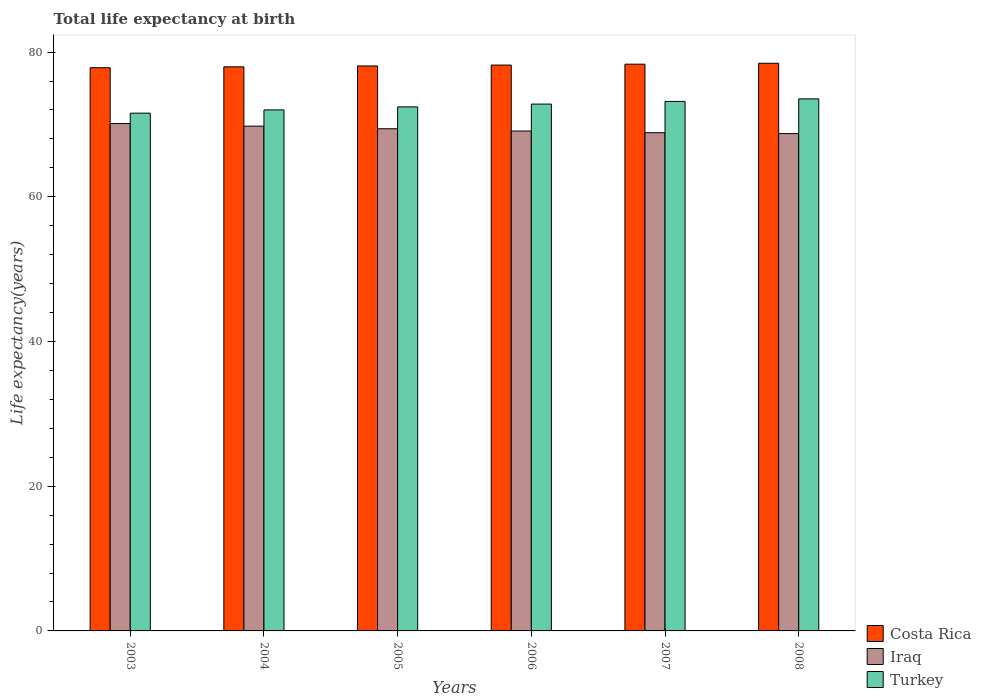How many different coloured bars are there?
Your answer should be very brief. 3. How many groups of bars are there?
Offer a terse response. 6. Are the number of bars per tick equal to the number of legend labels?
Keep it short and to the point. Yes. How many bars are there on the 3rd tick from the right?
Make the answer very short. 3. What is the label of the 6th group of bars from the left?
Make the answer very short. 2008. In how many cases, is the number of bars for a given year not equal to the number of legend labels?
Give a very brief answer. 0. What is the life expectancy at birth in in Costa Rica in 2007?
Your answer should be compact. 78.33. Across all years, what is the maximum life expectancy at birth in in Iraq?
Offer a very short reply. 70.12. Across all years, what is the minimum life expectancy at birth in in Turkey?
Make the answer very short. 71.56. In which year was the life expectancy at birth in in Iraq minimum?
Provide a succinct answer. 2008. What is the total life expectancy at birth in in Iraq in the graph?
Your answer should be compact. 415.99. What is the difference between the life expectancy at birth in in Iraq in 2006 and that in 2008?
Offer a very short reply. 0.36. What is the difference between the life expectancy at birth in in Iraq in 2007 and the life expectancy at birth in in Costa Rica in 2003?
Provide a succinct answer. -8.98. What is the average life expectancy at birth in in Turkey per year?
Give a very brief answer. 72.59. In the year 2003, what is the difference between the life expectancy at birth in in Turkey and life expectancy at birth in in Costa Rica?
Provide a short and direct response. -6.28. What is the ratio of the life expectancy at birth in in Costa Rica in 2003 to that in 2006?
Give a very brief answer. 1. What is the difference between the highest and the second highest life expectancy at birth in in Iraq?
Offer a very short reply. 0.35. What is the difference between the highest and the lowest life expectancy at birth in in Iraq?
Keep it short and to the point. 1.39. In how many years, is the life expectancy at birth in in Costa Rica greater than the average life expectancy at birth in in Costa Rica taken over all years?
Provide a succinct answer. 3. What does the 3rd bar from the left in 2004 represents?
Ensure brevity in your answer.  Turkey. What does the 2nd bar from the right in 2007 represents?
Make the answer very short. Iraq. Are all the bars in the graph horizontal?
Your answer should be compact. No. Are the values on the major ticks of Y-axis written in scientific E-notation?
Offer a terse response. No. Does the graph contain any zero values?
Your answer should be very brief. No. Does the graph contain grids?
Give a very brief answer. No. Where does the legend appear in the graph?
Your answer should be very brief. Bottom right. How are the legend labels stacked?
Keep it short and to the point. Vertical. What is the title of the graph?
Your response must be concise. Total life expectancy at birth. Does "Korea (Republic)" appear as one of the legend labels in the graph?
Your answer should be compact. No. What is the label or title of the Y-axis?
Offer a terse response. Life expectancy(years). What is the Life expectancy(years) of Costa Rica in 2003?
Keep it short and to the point. 77.84. What is the Life expectancy(years) in Iraq in 2003?
Make the answer very short. 70.12. What is the Life expectancy(years) of Turkey in 2003?
Your response must be concise. 71.56. What is the Life expectancy(years) of Costa Rica in 2004?
Provide a short and direct response. 77.97. What is the Life expectancy(years) in Iraq in 2004?
Provide a succinct answer. 69.77. What is the Life expectancy(years) of Turkey in 2004?
Keep it short and to the point. 72.01. What is the Life expectancy(years) in Costa Rica in 2005?
Provide a short and direct response. 78.09. What is the Life expectancy(years) of Iraq in 2005?
Make the answer very short. 69.41. What is the Life expectancy(years) of Turkey in 2005?
Give a very brief answer. 72.43. What is the Life expectancy(years) in Costa Rica in 2006?
Offer a terse response. 78.21. What is the Life expectancy(years) in Iraq in 2006?
Offer a very short reply. 69.09. What is the Life expectancy(years) in Turkey in 2006?
Make the answer very short. 72.82. What is the Life expectancy(years) in Costa Rica in 2007?
Ensure brevity in your answer.  78.33. What is the Life expectancy(years) of Iraq in 2007?
Make the answer very short. 68.86. What is the Life expectancy(years) in Turkey in 2007?
Make the answer very short. 73.18. What is the Life expectancy(years) of Costa Rica in 2008?
Provide a succinct answer. 78.46. What is the Life expectancy(years) in Iraq in 2008?
Provide a short and direct response. 68.73. What is the Life expectancy(years) in Turkey in 2008?
Ensure brevity in your answer.  73.53. Across all years, what is the maximum Life expectancy(years) in Costa Rica?
Provide a short and direct response. 78.46. Across all years, what is the maximum Life expectancy(years) of Iraq?
Ensure brevity in your answer.  70.12. Across all years, what is the maximum Life expectancy(years) in Turkey?
Provide a short and direct response. 73.53. Across all years, what is the minimum Life expectancy(years) of Costa Rica?
Provide a succinct answer. 77.84. Across all years, what is the minimum Life expectancy(years) of Iraq?
Ensure brevity in your answer.  68.73. Across all years, what is the minimum Life expectancy(years) in Turkey?
Offer a terse response. 71.56. What is the total Life expectancy(years) in Costa Rica in the graph?
Offer a very short reply. 468.89. What is the total Life expectancy(years) in Iraq in the graph?
Provide a succinct answer. 415.99. What is the total Life expectancy(years) in Turkey in the graph?
Give a very brief answer. 435.53. What is the difference between the Life expectancy(years) of Costa Rica in 2003 and that in 2004?
Keep it short and to the point. -0.12. What is the difference between the Life expectancy(years) in Iraq in 2003 and that in 2004?
Offer a very short reply. 0.35. What is the difference between the Life expectancy(years) of Turkey in 2003 and that in 2004?
Provide a succinct answer. -0.45. What is the difference between the Life expectancy(years) in Costa Rica in 2003 and that in 2005?
Ensure brevity in your answer.  -0.25. What is the difference between the Life expectancy(years) of Iraq in 2003 and that in 2005?
Offer a very short reply. 0.72. What is the difference between the Life expectancy(years) of Turkey in 2003 and that in 2005?
Ensure brevity in your answer.  -0.87. What is the difference between the Life expectancy(years) of Costa Rica in 2003 and that in 2006?
Provide a succinct answer. -0.37. What is the difference between the Life expectancy(years) in Iraq in 2003 and that in 2006?
Provide a short and direct response. 1.03. What is the difference between the Life expectancy(years) of Turkey in 2003 and that in 2006?
Provide a succinct answer. -1.26. What is the difference between the Life expectancy(years) in Costa Rica in 2003 and that in 2007?
Your response must be concise. -0.49. What is the difference between the Life expectancy(years) of Iraq in 2003 and that in 2007?
Ensure brevity in your answer.  1.26. What is the difference between the Life expectancy(years) of Turkey in 2003 and that in 2007?
Keep it short and to the point. -1.62. What is the difference between the Life expectancy(years) of Costa Rica in 2003 and that in 2008?
Your response must be concise. -0.62. What is the difference between the Life expectancy(years) in Iraq in 2003 and that in 2008?
Ensure brevity in your answer.  1.39. What is the difference between the Life expectancy(years) of Turkey in 2003 and that in 2008?
Offer a terse response. -1.97. What is the difference between the Life expectancy(years) in Costa Rica in 2004 and that in 2005?
Your response must be concise. -0.12. What is the difference between the Life expectancy(years) of Iraq in 2004 and that in 2005?
Offer a very short reply. 0.36. What is the difference between the Life expectancy(years) of Turkey in 2004 and that in 2005?
Ensure brevity in your answer.  -0.42. What is the difference between the Life expectancy(years) of Costa Rica in 2004 and that in 2006?
Your answer should be very brief. -0.24. What is the difference between the Life expectancy(years) of Iraq in 2004 and that in 2006?
Your response must be concise. 0.68. What is the difference between the Life expectancy(years) of Turkey in 2004 and that in 2006?
Give a very brief answer. -0.8. What is the difference between the Life expectancy(years) in Costa Rica in 2004 and that in 2007?
Your answer should be very brief. -0.36. What is the difference between the Life expectancy(years) of Iraq in 2004 and that in 2007?
Your answer should be compact. 0.91. What is the difference between the Life expectancy(years) in Turkey in 2004 and that in 2007?
Make the answer very short. -1.17. What is the difference between the Life expectancy(years) of Costa Rica in 2004 and that in 2008?
Offer a terse response. -0.49. What is the difference between the Life expectancy(years) in Iraq in 2004 and that in 2008?
Ensure brevity in your answer.  1.03. What is the difference between the Life expectancy(years) of Turkey in 2004 and that in 2008?
Offer a very short reply. -1.52. What is the difference between the Life expectancy(years) of Costa Rica in 2005 and that in 2006?
Keep it short and to the point. -0.12. What is the difference between the Life expectancy(years) in Iraq in 2005 and that in 2006?
Offer a very short reply. 0.32. What is the difference between the Life expectancy(years) of Turkey in 2005 and that in 2006?
Keep it short and to the point. -0.39. What is the difference between the Life expectancy(years) in Costa Rica in 2005 and that in 2007?
Ensure brevity in your answer.  -0.24. What is the difference between the Life expectancy(years) in Iraq in 2005 and that in 2007?
Provide a succinct answer. 0.55. What is the difference between the Life expectancy(years) of Turkey in 2005 and that in 2007?
Make the answer very short. -0.75. What is the difference between the Life expectancy(years) in Costa Rica in 2005 and that in 2008?
Keep it short and to the point. -0.37. What is the difference between the Life expectancy(years) in Iraq in 2005 and that in 2008?
Provide a succinct answer. 0.67. What is the difference between the Life expectancy(years) in Turkey in 2005 and that in 2008?
Your answer should be compact. -1.11. What is the difference between the Life expectancy(years) in Costa Rica in 2006 and that in 2007?
Offer a very short reply. -0.12. What is the difference between the Life expectancy(years) in Iraq in 2006 and that in 2007?
Provide a succinct answer. 0.23. What is the difference between the Life expectancy(years) of Turkey in 2006 and that in 2007?
Provide a short and direct response. -0.37. What is the difference between the Life expectancy(years) of Costa Rica in 2006 and that in 2008?
Give a very brief answer. -0.25. What is the difference between the Life expectancy(years) in Iraq in 2006 and that in 2008?
Give a very brief answer. 0.36. What is the difference between the Life expectancy(years) of Turkey in 2006 and that in 2008?
Ensure brevity in your answer.  -0.72. What is the difference between the Life expectancy(years) in Costa Rica in 2007 and that in 2008?
Ensure brevity in your answer.  -0.13. What is the difference between the Life expectancy(years) in Iraq in 2007 and that in 2008?
Make the answer very short. 0.12. What is the difference between the Life expectancy(years) in Turkey in 2007 and that in 2008?
Provide a short and direct response. -0.35. What is the difference between the Life expectancy(years) of Costa Rica in 2003 and the Life expectancy(years) of Iraq in 2004?
Keep it short and to the point. 8.07. What is the difference between the Life expectancy(years) in Costa Rica in 2003 and the Life expectancy(years) in Turkey in 2004?
Offer a terse response. 5.83. What is the difference between the Life expectancy(years) in Iraq in 2003 and the Life expectancy(years) in Turkey in 2004?
Your response must be concise. -1.89. What is the difference between the Life expectancy(years) in Costa Rica in 2003 and the Life expectancy(years) in Iraq in 2005?
Your response must be concise. 8.43. What is the difference between the Life expectancy(years) in Costa Rica in 2003 and the Life expectancy(years) in Turkey in 2005?
Provide a succinct answer. 5.41. What is the difference between the Life expectancy(years) of Iraq in 2003 and the Life expectancy(years) of Turkey in 2005?
Offer a very short reply. -2.3. What is the difference between the Life expectancy(years) of Costa Rica in 2003 and the Life expectancy(years) of Iraq in 2006?
Your answer should be compact. 8.75. What is the difference between the Life expectancy(years) of Costa Rica in 2003 and the Life expectancy(years) of Turkey in 2006?
Ensure brevity in your answer.  5.02. What is the difference between the Life expectancy(years) in Iraq in 2003 and the Life expectancy(years) in Turkey in 2006?
Your response must be concise. -2.69. What is the difference between the Life expectancy(years) of Costa Rica in 2003 and the Life expectancy(years) of Iraq in 2007?
Make the answer very short. 8.98. What is the difference between the Life expectancy(years) of Costa Rica in 2003 and the Life expectancy(years) of Turkey in 2007?
Offer a terse response. 4.66. What is the difference between the Life expectancy(years) of Iraq in 2003 and the Life expectancy(years) of Turkey in 2007?
Offer a very short reply. -3.06. What is the difference between the Life expectancy(years) of Costa Rica in 2003 and the Life expectancy(years) of Iraq in 2008?
Your answer should be very brief. 9.11. What is the difference between the Life expectancy(years) in Costa Rica in 2003 and the Life expectancy(years) in Turkey in 2008?
Give a very brief answer. 4.31. What is the difference between the Life expectancy(years) of Iraq in 2003 and the Life expectancy(years) of Turkey in 2008?
Offer a terse response. -3.41. What is the difference between the Life expectancy(years) in Costa Rica in 2004 and the Life expectancy(years) in Iraq in 2005?
Provide a short and direct response. 8.56. What is the difference between the Life expectancy(years) in Costa Rica in 2004 and the Life expectancy(years) in Turkey in 2005?
Provide a short and direct response. 5.54. What is the difference between the Life expectancy(years) of Iraq in 2004 and the Life expectancy(years) of Turkey in 2005?
Provide a short and direct response. -2.66. What is the difference between the Life expectancy(years) of Costa Rica in 2004 and the Life expectancy(years) of Iraq in 2006?
Make the answer very short. 8.87. What is the difference between the Life expectancy(years) in Costa Rica in 2004 and the Life expectancy(years) in Turkey in 2006?
Offer a terse response. 5.15. What is the difference between the Life expectancy(years) in Iraq in 2004 and the Life expectancy(years) in Turkey in 2006?
Make the answer very short. -3.05. What is the difference between the Life expectancy(years) of Costa Rica in 2004 and the Life expectancy(years) of Iraq in 2007?
Provide a succinct answer. 9.11. What is the difference between the Life expectancy(years) of Costa Rica in 2004 and the Life expectancy(years) of Turkey in 2007?
Offer a terse response. 4.78. What is the difference between the Life expectancy(years) of Iraq in 2004 and the Life expectancy(years) of Turkey in 2007?
Make the answer very short. -3.41. What is the difference between the Life expectancy(years) in Costa Rica in 2004 and the Life expectancy(years) in Iraq in 2008?
Your response must be concise. 9.23. What is the difference between the Life expectancy(years) of Costa Rica in 2004 and the Life expectancy(years) of Turkey in 2008?
Provide a short and direct response. 4.43. What is the difference between the Life expectancy(years) in Iraq in 2004 and the Life expectancy(years) in Turkey in 2008?
Your answer should be compact. -3.77. What is the difference between the Life expectancy(years) of Costa Rica in 2005 and the Life expectancy(years) of Iraq in 2006?
Your answer should be very brief. 9. What is the difference between the Life expectancy(years) in Costa Rica in 2005 and the Life expectancy(years) in Turkey in 2006?
Provide a short and direct response. 5.27. What is the difference between the Life expectancy(years) of Iraq in 2005 and the Life expectancy(years) of Turkey in 2006?
Offer a terse response. -3.41. What is the difference between the Life expectancy(years) of Costa Rica in 2005 and the Life expectancy(years) of Iraq in 2007?
Keep it short and to the point. 9.23. What is the difference between the Life expectancy(years) of Costa Rica in 2005 and the Life expectancy(years) of Turkey in 2007?
Provide a short and direct response. 4.9. What is the difference between the Life expectancy(years) in Iraq in 2005 and the Life expectancy(years) in Turkey in 2007?
Your answer should be compact. -3.77. What is the difference between the Life expectancy(years) in Costa Rica in 2005 and the Life expectancy(years) in Iraq in 2008?
Provide a succinct answer. 9.35. What is the difference between the Life expectancy(years) in Costa Rica in 2005 and the Life expectancy(years) in Turkey in 2008?
Make the answer very short. 4.55. What is the difference between the Life expectancy(years) in Iraq in 2005 and the Life expectancy(years) in Turkey in 2008?
Keep it short and to the point. -4.13. What is the difference between the Life expectancy(years) in Costa Rica in 2006 and the Life expectancy(years) in Iraq in 2007?
Offer a terse response. 9.35. What is the difference between the Life expectancy(years) of Costa Rica in 2006 and the Life expectancy(years) of Turkey in 2007?
Give a very brief answer. 5.03. What is the difference between the Life expectancy(years) in Iraq in 2006 and the Life expectancy(years) in Turkey in 2007?
Offer a terse response. -4.09. What is the difference between the Life expectancy(years) in Costa Rica in 2006 and the Life expectancy(years) in Iraq in 2008?
Make the answer very short. 9.47. What is the difference between the Life expectancy(years) in Costa Rica in 2006 and the Life expectancy(years) in Turkey in 2008?
Give a very brief answer. 4.67. What is the difference between the Life expectancy(years) in Iraq in 2006 and the Life expectancy(years) in Turkey in 2008?
Your answer should be compact. -4.44. What is the difference between the Life expectancy(years) in Costa Rica in 2007 and the Life expectancy(years) in Iraq in 2008?
Offer a terse response. 9.6. What is the difference between the Life expectancy(years) in Costa Rica in 2007 and the Life expectancy(years) in Turkey in 2008?
Ensure brevity in your answer.  4.8. What is the difference between the Life expectancy(years) of Iraq in 2007 and the Life expectancy(years) of Turkey in 2008?
Your response must be concise. -4.67. What is the average Life expectancy(years) of Costa Rica per year?
Provide a succinct answer. 78.15. What is the average Life expectancy(years) in Iraq per year?
Give a very brief answer. 69.33. What is the average Life expectancy(years) of Turkey per year?
Your answer should be compact. 72.59. In the year 2003, what is the difference between the Life expectancy(years) of Costa Rica and Life expectancy(years) of Iraq?
Offer a terse response. 7.72. In the year 2003, what is the difference between the Life expectancy(years) of Costa Rica and Life expectancy(years) of Turkey?
Your answer should be compact. 6.28. In the year 2003, what is the difference between the Life expectancy(years) of Iraq and Life expectancy(years) of Turkey?
Keep it short and to the point. -1.44. In the year 2004, what is the difference between the Life expectancy(years) in Costa Rica and Life expectancy(years) in Iraq?
Your answer should be very brief. 8.2. In the year 2004, what is the difference between the Life expectancy(years) in Costa Rica and Life expectancy(years) in Turkey?
Your answer should be very brief. 5.95. In the year 2004, what is the difference between the Life expectancy(years) in Iraq and Life expectancy(years) in Turkey?
Make the answer very short. -2.24. In the year 2005, what is the difference between the Life expectancy(years) of Costa Rica and Life expectancy(years) of Iraq?
Offer a terse response. 8.68. In the year 2005, what is the difference between the Life expectancy(years) of Costa Rica and Life expectancy(years) of Turkey?
Your answer should be very brief. 5.66. In the year 2005, what is the difference between the Life expectancy(years) of Iraq and Life expectancy(years) of Turkey?
Give a very brief answer. -3.02. In the year 2006, what is the difference between the Life expectancy(years) of Costa Rica and Life expectancy(years) of Iraq?
Your answer should be very brief. 9.12. In the year 2006, what is the difference between the Life expectancy(years) in Costa Rica and Life expectancy(years) in Turkey?
Offer a terse response. 5.39. In the year 2006, what is the difference between the Life expectancy(years) in Iraq and Life expectancy(years) in Turkey?
Your answer should be compact. -3.72. In the year 2007, what is the difference between the Life expectancy(years) in Costa Rica and Life expectancy(years) in Iraq?
Provide a succinct answer. 9.47. In the year 2007, what is the difference between the Life expectancy(years) of Costa Rica and Life expectancy(years) of Turkey?
Your answer should be very brief. 5.15. In the year 2007, what is the difference between the Life expectancy(years) of Iraq and Life expectancy(years) of Turkey?
Give a very brief answer. -4.32. In the year 2008, what is the difference between the Life expectancy(years) in Costa Rica and Life expectancy(years) in Iraq?
Keep it short and to the point. 9.72. In the year 2008, what is the difference between the Life expectancy(years) in Costa Rica and Life expectancy(years) in Turkey?
Your response must be concise. 4.92. In the year 2008, what is the difference between the Life expectancy(years) of Iraq and Life expectancy(years) of Turkey?
Make the answer very short. -4.8. What is the ratio of the Life expectancy(years) of Costa Rica in 2003 to that in 2004?
Provide a short and direct response. 1. What is the ratio of the Life expectancy(years) in Turkey in 2003 to that in 2004?
Your answer should be very brief. 0.99. What is the ratio of the Life expectancy(years) in Costa Rica in 2003 to that in 2005?
Offer a terse response. 1. What is the ratio of the Life expectancy(years) in Iraq in 2003 to that in 2005?
Provide a succinct answer. 1.01. What is the ratio of the Life expectancy(years) of Iraq in 2003 to that in 2006?
Provide a short and direct response. 1.01. What is the ratio of the Life expectancy(years) of Turkey in 2003 to that in 2006?
Provide a succinct answer. 0.98. What is the ratio of the Life expectancy(years) in Costa Rica in 2003 to that in 2007?
Provide a short and direct response. 0.99. What is the ratio of the Life expectancy(years) of Iraq in 2003 to that in 2007?
Make the answer very short. 1.02. What is the ratio of the Life expectancy(years) of Turkey in 2003 to that in 2007?
Your answer should be very brief. 0.98. What is the ratio of the Life expectancy(years) of Costa Rica in 2003 to that in 2008?
Your response must be concise. 0.99. What is the ratio of the Life expectancy(years) in Iraq in 2003 to that in 2008?
Offer a terse response. 1.02. What is the ratio of the Life expectancy(years) in Turkey in 2003 to that in 2008?
Make the answer very short. 0.97. What is the ratio of the Life expectancy(years) in Turkey in 2004 to that in 2005?
Make the answer very short. 0.99. What is the ratio of the Life expectancy(years) in Iraq in 2004 to that in 2006?
Ensure brevity in your answer.  1.01. What is the ratio of the Life expectancy(years) of Turkey in 2004 to that in 2006?
Your answer should be very brief. 0.99. What is the ratio of the Life expectancy(years) of Costa Rica in 2004 to that in 2007?
Provide a short and direct response. 1. What is the ratio of the Life expectancy(years) of Iraq in 2004 to that in 2007?
Your answer should be very brief. 1.01. What is the ratio of the Life expectancy(years) in Turkey in 2004 to that in 2007?
Your response must be concise. 0.98. What is the ratio of the Life expectancy(years) of Costa Rica in 2004 to that in 2008?
Provide a succinct answer. 0.99. What is the ratio of the Life expectancy(years) of Iraq in 2004 to that in 2008?
Your answer should be compact. 1.01. What is the ratio of the Life expectancy(years) of Turkey in 2004 to that in 2008?
Ensure brevity in your answer.  0.98. What is the ratio of the Life expectancy(years) of Costa Rica in 2005 to that in 2006?
Give a very brief answer. 1. What is the ratio of the Life expectancy(years) in Iraq in 2005 to that in 2006?
Provide a short and direct response. 1. What is the ratio of the Life expectancy(years) in Turkey in 2005 to that in 2006?
Ensure brevity in your answer.  0.99. What is the ratio of the Life expectancy(years) in Turkey in 2005 to that in 2007?
Your response must be concise. 0.99. What is the ratio of the Life expectancy(years) of Costa Rica in 2005 to that in 2008?
Your answer should be compact. 1. What is the ratio of the Life expectancy(years) of Iraq in 2005 to that in 2008?
Offer a very short reply. 1.01. What is the ratio of the Life expectancy(years) of Turkey in 2005 to that in 2008?
Give a very brief answer. 0.98. What is the ratio of the Life expectancy(years) of Turkey in 2006 to that in 2007?
Offer a very short reply. 0.99. What is the ratio of the Life expectancy(years) of Costa Rica in 2006 to that in 2008?
Make the answer very short. 1. What is the ratio of the Life expectancy(years) of Iraq in 2006 to that in 2008?
Ensure brevity in your answer.  1.01. What is the ratio of the Life expectancy(years) of Turkey in 2006 to that in 2008?
Offer a terse response. 0.99. What is the difference between the highest and the second highest Life expectancy(years) of Costa Rica?
Your answer should be very brief. 0.13. What is the difference between the highest and the second highest Life expectancy(years) of Iraq?
Offer a very short reply. 0.35. What is the difference between the highest and the second highest Life expectancy(years) of Turkey?
Keep it short and to the point. 0.35. What is the difference between the highest and the lowest Life expectancy(years) of Costa Rica?
Your response must be concise. 0.62. What is the difference between the highest and the lowest Life expectancy(years) in Iraq?
Your answer should be compact. 1.39. What is the difference between the highest and the lowest Life expectancy(years) in Turkey?
Make the answer very short. 1.97. 